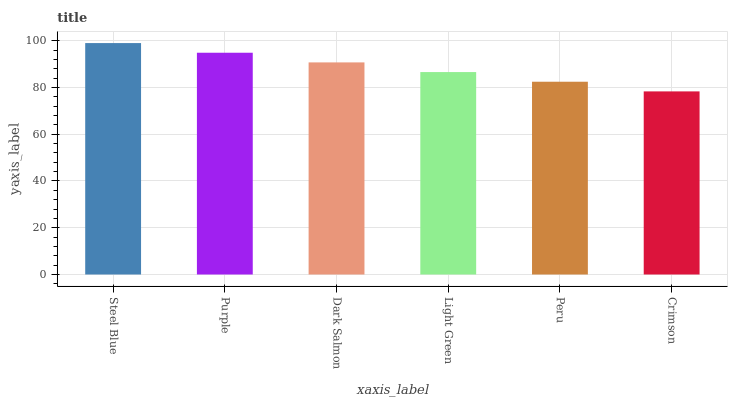Is Crimson the minimum?
Answer yes or no. Yes. Is Steel Blue the maximum?
Answer yes or no. Yes. Is Purple the minimum?
Answer yes or no. No. Is Purple the maximum?
Answer yes or no. No. Is Steel Blue greater than Purple?
Answer yes or no. Yes. Is Purple less than Steel Blue?
Answer yes or no. Yes. Is Purple greater than Steel Blue?
Answer yes or no. No. Is Steel Blue less than Purple?
Answer yes or no. No. Is Dark Salmon the high median?
Answer yes or no. Yes. Is Light Green the low median?
Answer yes or no. Yes. Is Crimson the high median?
Answer yes or no. No. Is Peru the low median?
Answer yes or no. No. 